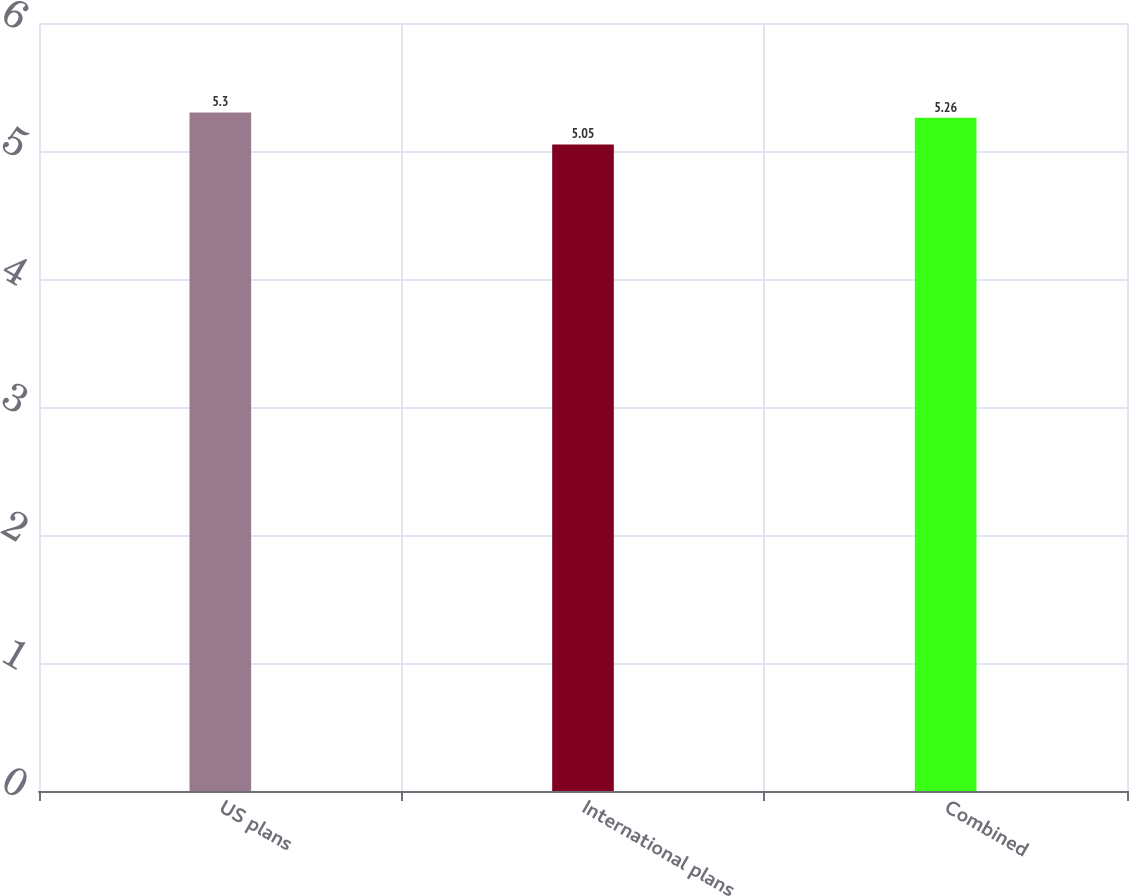<chart> <loc_0><loc_0><loc_500><loc_500><bar_chart><fcel>US plans<fcel>International plans<fcel>Combined<nl><fcel>5.3<fcel>5.05<fcel>5.26<nl></chart> 